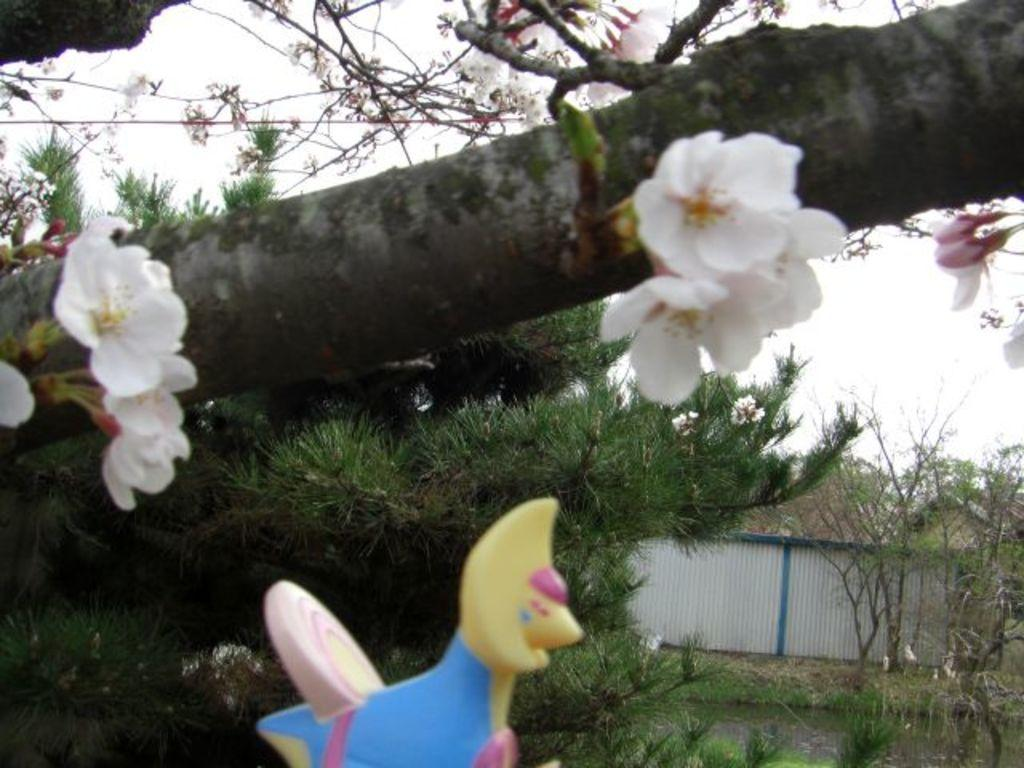What object can be seen in the image that is typically used for play? There is a toy in the image. What natural element is present in the image that is not a tree? There is a tree branch with flowers in the image. What type of structures can be seen in the background of the image? There is a shed in the background of the image. What type of vegetation is visible in the background of the image? There are trees in the background of the image. What architectural feature is visible in the background of the image? There is a wall in the background of the image. What part of the natural environment is visible in the background of the image? The sky is visible in the background of the image. What type of farm animals can be seen grazing in the image? There are no farm animals present in the image. What type of cellar can be seen in the image? There is no cellar present in the image. 